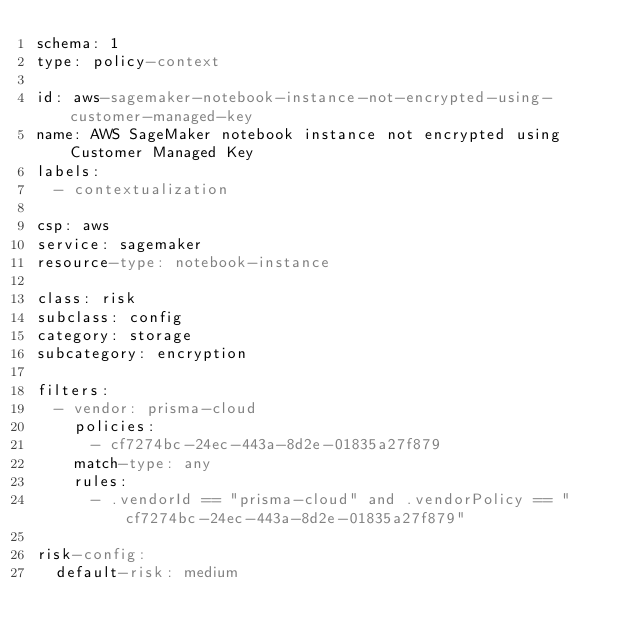<code> <loc_0><loc_0><loc_500><loc_500><_YAML_>schema: 1
type: policy-context
 
id: aws-sagemaker-notebook-instance-not-encrypted-using-customer-managed-key
name: AWS SageMaker notebook instance not encrypted using Customer Managed Key
labels:
  - contextualization
 
csp: aws
service: sagemaker
resource-type: notebook-instance
 
class: risk
subclass: config
category: storage
subcategory: encryption
 
filters:
  - vendor: prisma-cloud
    policies:
      - cf7274bc-24ec-443a-8d2e-01835a27f879
    match-type: any
    rules:
      - .vendorId == "prisma-cloud" and .vendorPolicy == "cf7274bc-24ec-443a-8d2e-01835a27f879"
 
risk-config:
  default-risk: medium
</code> 